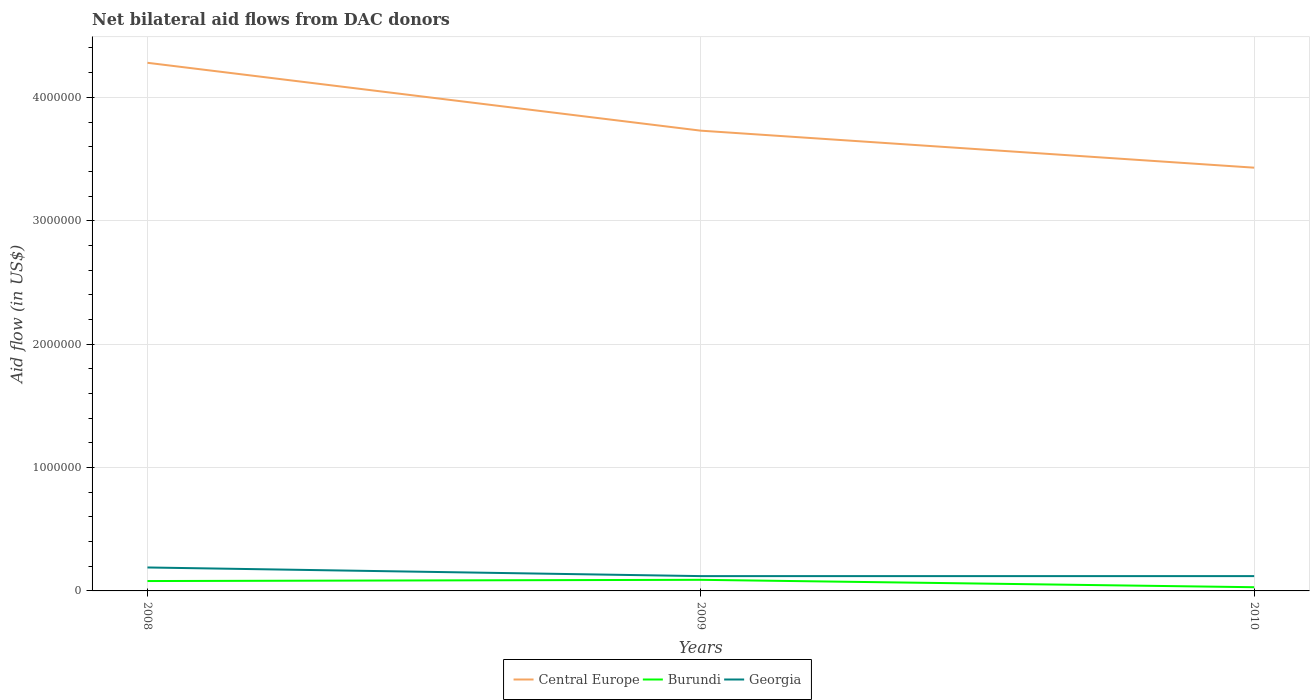How many different coloured lines are there?
Give a very brief answer. 3. Across all years, what is the maximum net bilateral aid flow in Central Europe?
Keep it short and to the point. 3.43e+06. In which year was the net bilateral aid flow in Central Europe maximum?
Provide a succinct answer. 2010. What is the total net bilateral aid flow in Central Europe in the graph?
Offer a very short reply. 3.00e+05. What is the difference between the highest and the second highest net bilateral aid flow in Burundi?
Ensure brevity in your answer.  6.00e+04. How many years are there in the graph?
Your response must be concise. 3. What is the difference between two consecutive major ticks on the Y-axis?
Your response must be concise. 1.00e+06. Are the values on the major ticks of Y-axis written in scientific E-notation?
Offer a very short reply. No. Does the graph contain any zero values?
Your answer should be compact. No. Where does the legend appear in the graph?
Ensure brevity in your answer.  Bottom center. How are the legend labels stacked?
Give a very brief answer. Horizontal. What is the title of the graph?
Give a very brief answer. Net bilateral aid flows from DAC donors. What is the label or title of the X-axis?
Make the answer very short. Years. What is the label or title of the Y-axis?
Provide a short and direct response. Aid flow (in US$). What is the Aid flow (in US$) in Central Europe in 2008?
Your response must be concise. 4.28e+06. What is the Aid flow (in US$) of Burundi in 2008?
Your response must be concise. 8.00e+04. What is the Aid flow (in US$) in Central Europe in 2009?
Offer a very short reply. 3.73e+06. What is the Aid flow (in US$) of Burundi in 2009?
Your response must be concise. 9.00e+04. What is the Aid flow (in US$) of Georgia in 2009?
Ensure brevity in your answer.  1.20e+05. What is the Aid flow (in US$) of Central Europe in 2010?
Your answer should be compact. 3.43e+06. What is the Aid flow (in US$) of Burundi in 2010?
Provide a succinct answer. 3.00e+04. What is the Aid flow (in US$) in Georgia in 2010?
Your answer should be compact. 1.20e+05. Across all years, what is the maximum Aid flow (in US$) of Central Europe?
Offer a terse response. 4.28e+06. Across all years, what is the minimum Aid flow (in US$) in Central Europe?
Give a very brief answer. 3.43e+06. Across all years, what is the minimum Aid flow (in US$) in Georgia?
Keep it short and to the point. 1.20e+05. What is the total Aid flow (in US$) in Central Europe in the graph?
Your answer should be very brief. 1.14e+07. What is the total Aid flow (in US$) of Burundi in the graph?
Your answer should be compact. 2.00e+05. What is the total Aid flow (in US$) in Georgia in the graph?
Ensure brevity in your answer.  4.30e+05. What is the difference between the Aid flow (in US$) of Burundi in 2008 and that in 2009?
Offer a terse response. -10000. What is the difference between the Aid flow (in US$) of Georgia in 2008 and that in 2009?
Ensure brevity in your answer.  7.00e+04. What is the difference between the Aid flow (in US$) of Central Europe in 2008 and that in 2010?
Your answer should be very brief. 8.50e+05. What is the difference between the Aid flow (in US$) of Burundi in 2008 and that in 2010?
Your answer should be very brief. 5.00e+04. What is the difference between the Aid flow (in US$) in Central Europe in 2009 and that in 2010?
Your answer should be compact. 3.00e+05. What is the difference between the Aid flow (in US$) of Burundi in 2009 and that in 2010?
Offer a terse response. 6.00e+04. What is the difference between the Aid flow (in US$) in Georgia in 2009 and that in 2010?
Your response must be concise. 0. What is the difference between the Aid flow (in US$) in Central Europe in 2008 and the Aid flow (in US$) in Burundi in 2009?
Ensure brevity in your answer.  4.19e+06. What is the difference between the Aid flow (in US$) in Central Europe in 2008 and the Aid flow (in US$) in Georgia in 2009?
Make the answer very short. 4.16e+06. What is the difference between the Aid flow (in US$) in Central Europe in 2008 and the Aid flow (in US$) in Burundi in 2010?
Provide a succinct answer. 4.25e+06. What is the difference between the Aid flow (in US$) of Central Europe in 2008 and the Aid flow (in US$) of Georgia in 2010?
Ensure brevity in your answer.  4.16e+06. What is the difference between the Aid flow (in US$) in Burundi in 2008 and the Aid flow (in US$) in Georgia in 2010?
Make the answer very short. -4.00e+04. What is the difference between the Aid flow (in US$) in Central Europe in 2009 and the Aid flow (in US$) in Burundi in 2010?
Offer a very short reply. 3.70e+06. What is the difference between the Aid flow (in US$) in Central Europe in 2009 and the Aid flow (in US$) in Georgia in 2010?
Your answer should be compact. 3.61e+06. What is the difference between the Aid flow (in US$) of Burundi in 2009 and the Aid flow (in US$) of Georgia in 2010?
Keep it short and to the point. -3.00e+04. What is the average Aid flow (in US$) of Central Europe per year?
Make the answer very short. 3.81e+06. What is the average Aid flow (in US$) in Burundi per year?
Your answer should be compact. 6.67e+04. What is the average Aid flow (in US$) in Georgia per year?
Make the answer very short. 1.43e+05. In the year 2008, what is the difference between the Aid flow (in US$) in Central Europe and Aid flow (in US$) in Burundi?
Make the answer very short. 4.20e+06. In the year 2008, what is the difference between the Aid flow (in US$) in Central Europe and Aid flow (in US$) in Georgia?
Provide a short and direct response. 4.09e+06. In the year 2009, what is the difference between the Aid flow (in US$) in Central Europe and Aid flow (in US$) in Burundi?
Ensure brevity in your answer.  3.64e+06. In the year 2009, what is the difference between the Aid flow (in US$) in Central Europe and Aid flow (in US$) in Georgia?
Provide a short and direct response. 3.61e+06. In the year 2010, what is the difference between the Aid flow (in US$) in Central Europe and Aid flow (in US$) in Burundi?
Offer a terse response. 3.40e+06. In the year 2010, what is the difference between the Aid flow (in US$) of Central Europe and Aid flow (in US$) of Georgia?
Your answer should be compact. 3.31e+06. In the year 2010, what is the difference between the Aid flow (in US$) in Burundi and Aid flow (in US$) in Georgia?
Offer a terse response. -9.00e+04. What is the ratio of the Aid flow (in US$) in Central Europe in 2008 to that in 2009?
Your response must be concise. 1.15. What is the ratio of the Aid flow (in US$) in Georgia in 2008 to that in 2009?
Ensure brevity in your answer.  1.58. What is the ratio of the Aid flow (in US$) of Central Europe in 2008 to that in 2010?
Offer a terse response. 1.25. What is the ratio of the Aid flow (in US$) in Burundi in 2008 to that in 2010?
Provide a short and direct response. 2.67. What is the ratio of the Aid flow (in US$) of Georgia in 2008 to that in 2010?
Your answer should be compact. 1.58. What is the ratio of the Aid flow (in US$) in Central Europe in 2009 to that in 2010?
Give a very brief answer. 1.09. What is the ratio of the Aid flow (in US$) in Burundi in 2009 to that in 2010?
Make the answer very short. 3. What is the ratio of the Aid flow (in US$) of Georgia in 2009 to that in 2010?
Offer a terse response. 1. What is the difference between the highest and the second highest Aid flow (in US$) in Georgia?
Offer a very short reply. 7.00e+04. What is the difference between the highest and the lowest Aid flow (in US$) of Central Europe?
Make the answer very short. 8.50e+05. 